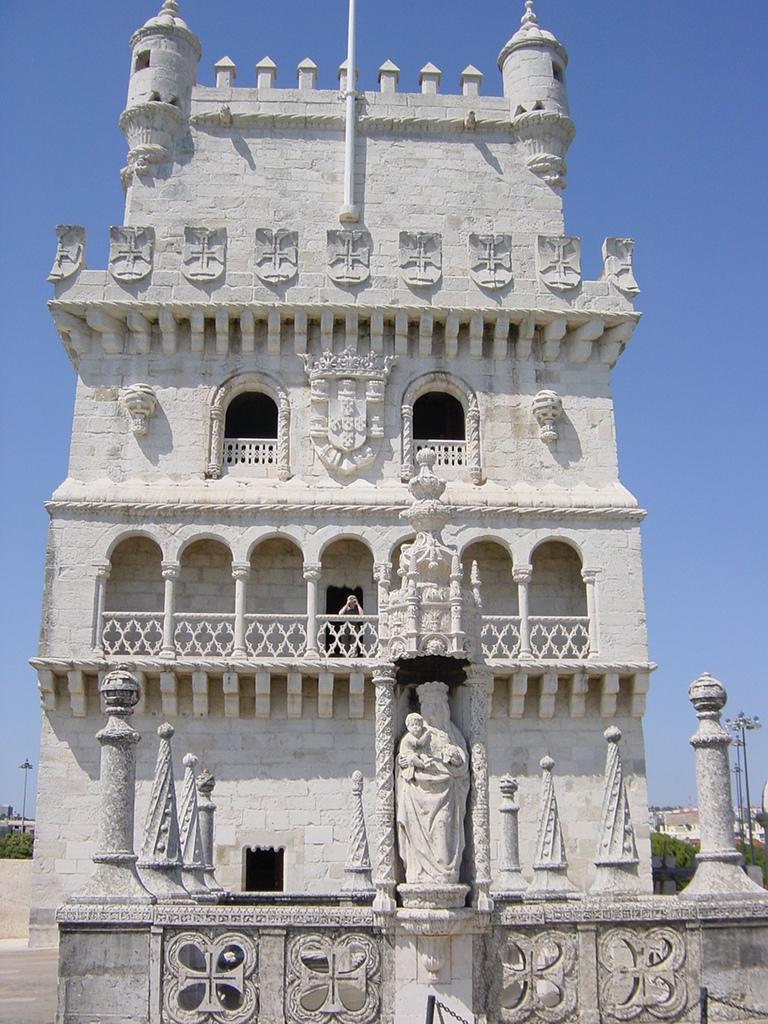Describe this image in one or two sentences. In this image we can see a building with windows, railing, statues and group of poles. In the background, we can see a group of trees, light poles and the sky. 